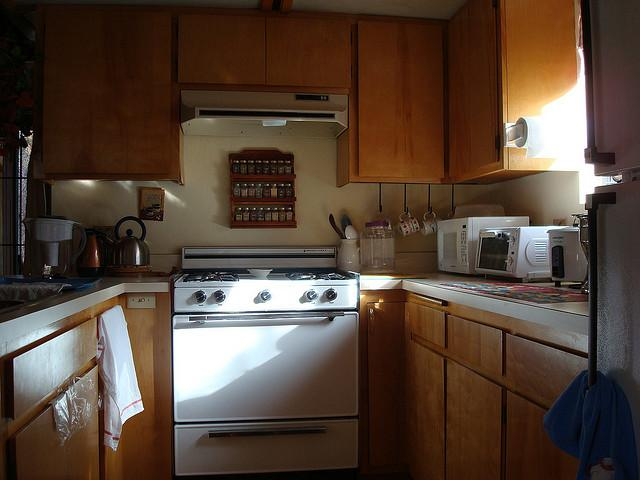What would someone use the objects above the stove for? cooking 